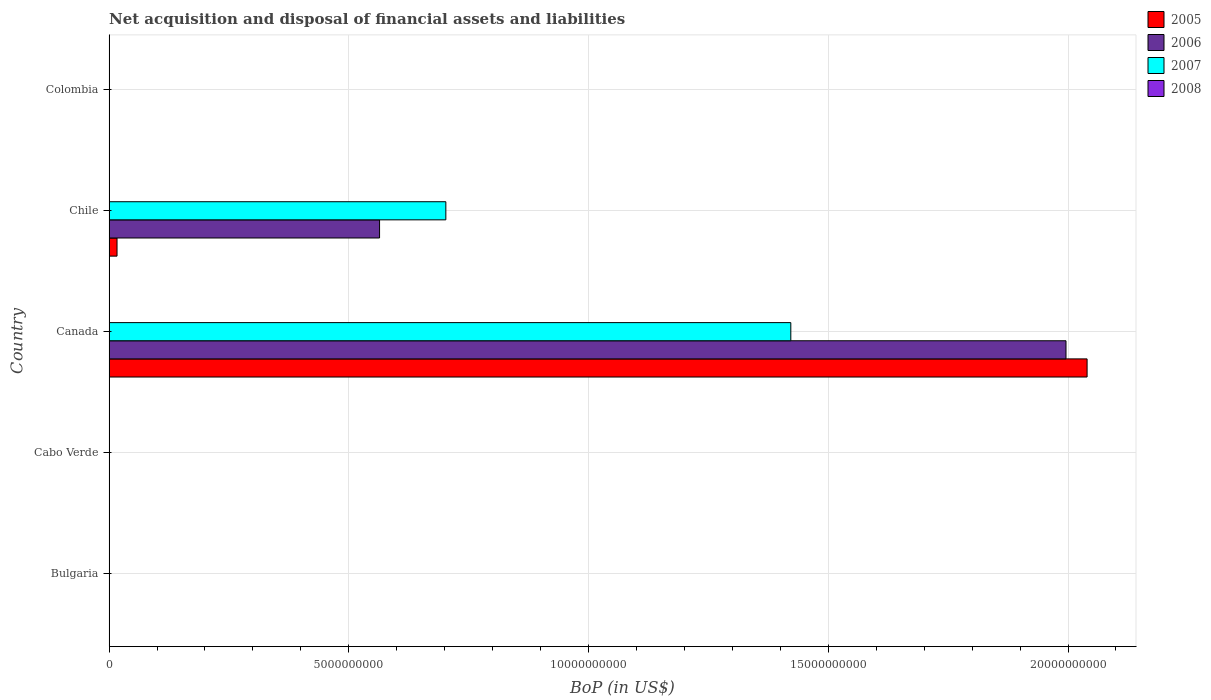How many different coloured bars are there?
Your answer should be compact. 3. What is the label of the 3rd group of bars from the top?
Ensure brevity in your answer.  Canada. Across all countries, what is the maximum Balance of Payments in 2006?
Keep it short and to the point. 2.00e+1. What is the total Balance of Payments in 2005 in the graph?
Provide a short and direct response. 2.06e+1. What is the difference between the Balance of Payments in 2005 in Canada and that in Chile?
Make the answer very short. 2.02e+1. What is the average Balance of Payments in 2007 per country?
Give a very brief answer. 4.25e+09. What is the difference between the Balance of Payments in 2007 and Balance of Payments in 2006 in Chile?
Your answer should be compact. 1.38e+09. What is the difference between the highest and the lowest Balance of Payments in 2006?
Ensure brevity in your answer.  2.00e+1. Is it the case that in every country, the sum of the Balance of Payments in 2005 and Balance of Payments in 2007 is greater than the sum of Balance of Payments in 2006 and Balance of Payments in 2008?
Provide a short and direct response. No. Is it the case that in every country, the sum of the Balance of Payments in 2008 and Balance of Payments in 2005 is greater than the Balance of Payments in 2006?
Keep it short and to the point. No. How many bars are there?
Provide a short and direct response. 6. Are all the bars in the graph horizontal?
Your answer should be compact. Yes. How many countries are there in the graph?
Provide a succinct answer. 5. What is the difference between two consecutive major ticks on the X-axis?
Your answer should be compact. 5.00e+09. Does the graph contain any zero values?
Keep it short and to the point. Yes. Does the graph contain grids?
Offer a very short reply. Yes. What is the title of the graph?
Your response must be concise. Net acquisition and disposal of financial assets and liabilities. What is the label or title of the X-axis?
Offer a terse response. BoP (in US$). What is the BoP (in US$) of 2005 in Cabo Verde?
Offer a very short reply. 0. What is the BoP (in US$) of 2005 in Canada?
Offer a very short reply. 2.04e+1. What is the BoP (in US$) in 2006 in Canada?
Offer a very short reply. 2.00e+1. What is the BoP (in US$) of 2007 in Canada?
Ensure brevity in your answer.  1.42e+1. What is the BoP (in US$) in 2005 in Chile?
Offer a very short reply. 1.66e+08. What is the BoP (in US$) of 2006 in Chile?
Provide a succinct answer. 5.64e+09. What is the BoP (in US$) in 2007 in Chile?
Your answer should be compact. 7.02e+09. What is the BoP (in US$) in 2007 in Colombia?
Offer a very short reply. 0. Across all countries, what is the maximum BoP (in US$) in 2005?
Your response must be concise. 2.04e+1. Across all countries, what is the maximum BoP (in US$) of 2006?
Your answer should be compact. 2.00e+1. Across all countries, what is the maximum BoP (in US$) in 2007?
Your response must be concise. 1.42e+1. Across all countries, what is the minimum BoP (in US$) in 2005?
Provide a succinct answer. 0. Across all countries, what is the minimum BoP (in US$) of 2006?
Offer a terse response. 0. Across all countries, what is the minimum BoP (in US$) of 2007?
Provide a succinct answer. 0. What is the total BoP (in US$) of 2005 in the graph?
Give a very brief answer. 2.06e+1. What is the total BoP (in US$) in 2006 in the graph?
Your answer should be compact. 2.56e+1. What is the total BoP (in US$) in 2007 in the graph?
Keep it short and to the point. 2.12e+1. What is the total BoP (in US$) of 2008 in the graph?
Make the answer very short. 0. What is the difference between the BoP (in US$) in 2005 in Canada and that in Chile?
Your answer should be very brief. 2.02e+1. What is the difference between the BoP (in US$) of 2006 in Canada and that in Chile?
Offer a terse response. 1.43e+1. What is the difference between the BoP (in US$) in 2007 in Canada and that in Chile?
Offer a very short reply. 7.19e+09. What is the difference between the BoP (in US$) of 2005 in Canada and the BoP (in US$) of 2006 in Chile?
Your answer should be very brief. 1.48e+1. What is the difference between the BoP (in US$) in 2005 in Canada and the BoP (in US$) in 2007 in Chile?
Make the answer very short. 1.34e+1. What is the difference between the BoP (in US$) in 2006 in Canada and the BoP (in US$) in 2007 in Chile?
Provide a succinct answer. 1.29e+1. What is the average BoP (in US$) in 2005 per country?
Make the answer very short. 4.11e+09. What is the average BoP (in US$) in 2006 per country?
Provide a short and direct response. 5.12e+09. What is the average BoP (in US$) in 2007 per country?
Give a very brief answer. 4.25e+09. What is the difference between the BoP (in US$) of 2005 and BoP (in US$) of 2006 in Canada?
Your answer should be very brief. 4.40e+08. What is the difference between the BoP (in US$) of 2005 and BoP (in US$) of 2007 in Canada?
Your response must be concise. 6.18e+09. What is the difference between the BoP (in US$) in 2006 and BoP (in US$) in 2007 in Canada?
Give a very brief answer. 5.74e+09. What is the difference between the BoP (in US$) of 2005 and BoP (in US$) of 2006 in Chile?
Offer a very short reply. -5.48e+09. What is the difference between the BoP (in US$) of 2005 and BoP (in US$) of 2007 in Chile?
Provide a short and direct response. -6.86e+09. What is the difference between the BoP (in US$) in 2006 and BoP (in US$) in 2007 in Chile?
Your answer should be very brief. -1.38e+09. What is the ratio of the BoP (in US$) in 2005 in Canada to that in Chile?
Your answer should be compact. 122.81. What is the ratio of the BoP (in US$) in 2006 in Canada to that in Chile?
Give a very brief answer. 3.54. What is the ratio of the BoP (in US$) of 2007 in Canada to that in Chile?
Keep it short and to the point. 2.02. What is the difference between the highest and the lowest BoP (in US$) of 2005?
Provide a succinct answer. 2.04e+1. What is the difference between the highest and the lowest BoP (in US$) in 2006?
Your response must be concise. 2.00e+1. What is the difference between the highest and the lowest BoP (in US$) of 2007?
Your answer should be very brief. 1.42e+1. 